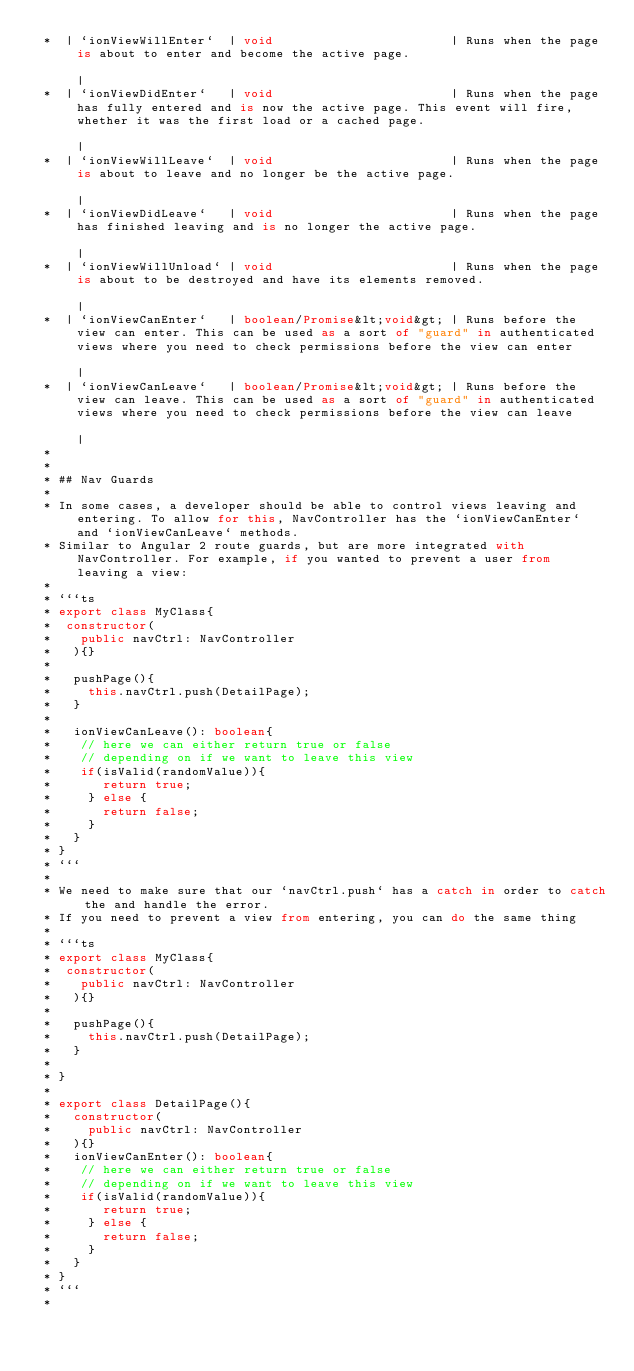Convert code to text. <code><loc_0><loc_0><loc_500><loc_500><_TypeScript_> *  | `ionViewWillEnter`  | void                        | Runs when the page is about to enter and become the active page.                                                                                                                                                                                               |
 *  | `ionViewDidEnter`   | void                        | Runs when the page has fully entered and is now the active page. This event will fire, whether it was the first load or a cached page.                                                                                                                         |
 *  | `ionViewWillLeave`  | void                        | Runs when the page is about to leave and no longer be the active page.                                                                                                                                                                                         |
 *  | `ionViewDidLeave`   | void                        | Runs when the page has finished leaving and is no longer the active page.                                                                                                                                                                                      |
 *  | `ionViewWillUnload` | void                        | Runs when the page is about to be destroyed and have its elements removed.                                                                                                                                                                                     |
 *  | `ionViewCanEnter`   | boolean/Promise&lt;void&gt; | Runs before the view can enter. This can be used as a sort of "guard" in authenticated views where you need to check permissions before the view can enter                                                                                                     |
 *  | `ionViewCanLeave`   | boolean/Promise&lt;void&gt; | Runs before the view can leave. This can be used as a sort of "guard" in authenticated views where you need to check permissions before the view can leave                                                                                                     |
 *
 *
 * ## Nav Guards
 *
 * In some cases, a developer should be able to control views leaving and entering. To allow for this, NavController has the `ionViewCanEnter` and `ionViewCanLeave` methods.
 * Similar to Angular 2 route guards, but are more integrated with NavController. For example, if you wanted to prevent a user from leaving a view:
 *
 * ```ts
 * export class MyClass{
 *  constructor(
 *    public navCtrl: NavController
 *   ){}
 *
 *   pushPage(){
 *     this.navCtrl.push(DetailPage);
 *   }
 *
 *   ionViewCanLeave(): boolean{
 *    // here we can either return true or false
 *    // depending on if we want to leave this view
 *    if(isValid(randomValue)){
 *       return true;
 *     } else {
 *       return false;
 *     }
 *   }
 * }
 * ```
 *
 * We need to make sure that our `navCtrl.push` has a catch in order to catch the and handle the error.
 * If you need to prevent a view from entering, you can do the same thing
 *
 * ```ts
 * export class MyClass{
 *  constructor(
 *    public navCtrl: NavController
 *   ){}
 *
 *   pushPage(){
 *     this.navCtrl.push(DetailPage);
 *   }
 *
 * }
 *
 * export class DetailPage(){
 *   constructor(
 *     public navCtrl: NavController
 *   ){}
 *   ionViewCanEnter(): boolean{
 *    // here we can either return true or false
 *    // depending on if we want to leave this view
 *    if(isValid(randomValue)){
 *       return true;
 *     } else {
 *       return false;
 *     }
 *   }
 * }
 * ```
 *</code> 